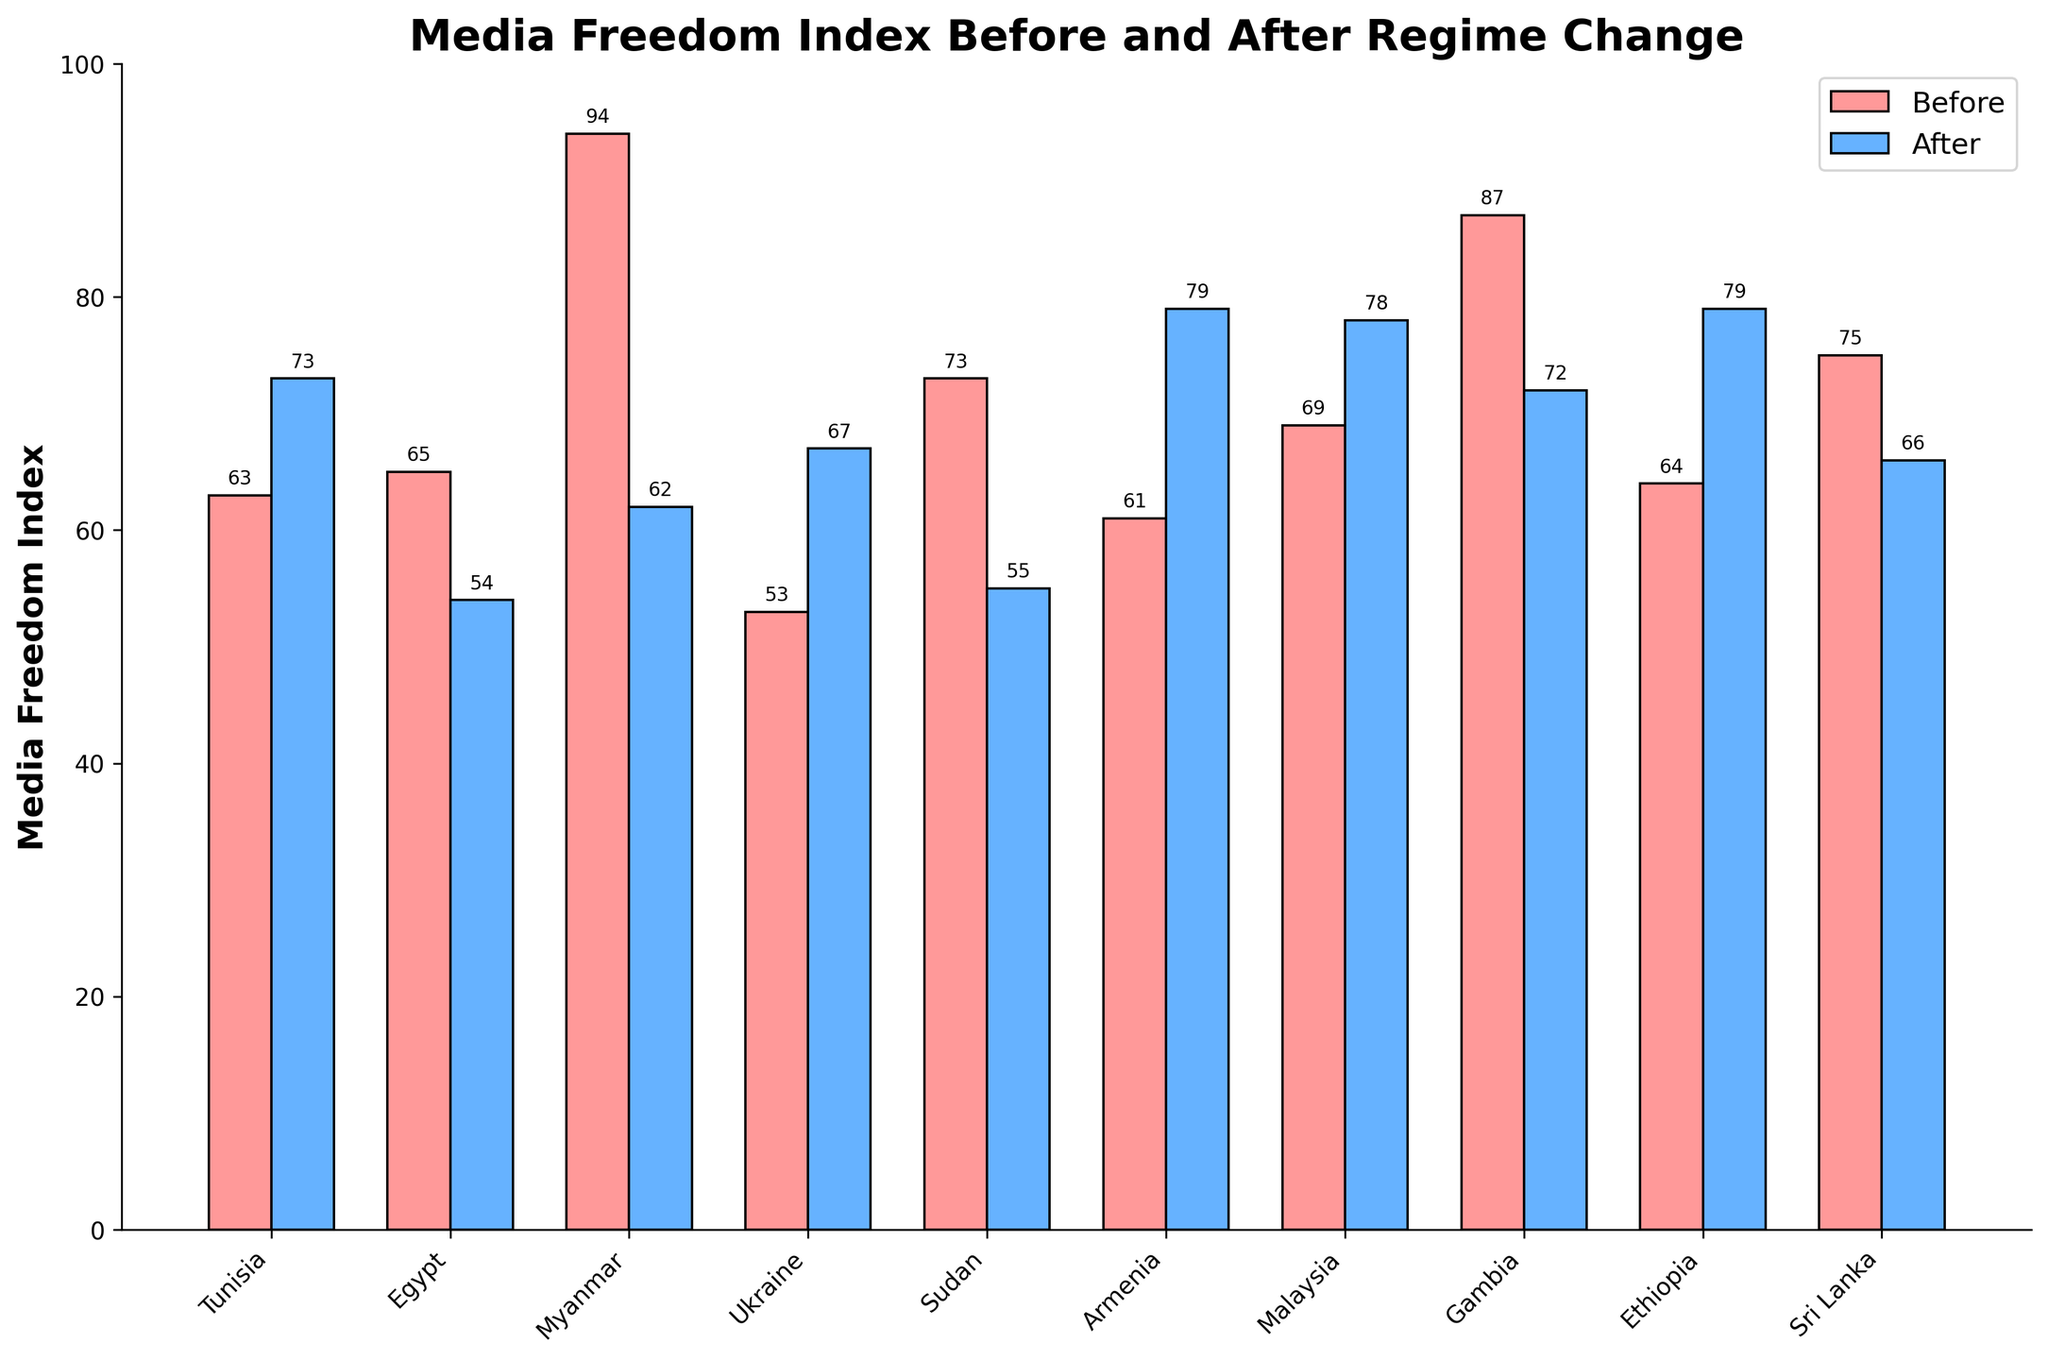Which country had the largest increase in media freedom index after regime change? Compare the "Before" and "After" values for each country and identify the one with the largest positive difference. Armenia had an increase from 61 to 79, which is 18 points, the largest increase.
Answer: Armenia Which country had a decrease in its media freedom index after regime change? Identify countries where the "After" value is less than the "Before" value. Egypt (65 to 54), Sudan (73 to 55), Sri Lanka (75 to 66), and Gambia (87 to 72) all had decreases.
Answer: Egypt, Sudan, Sri Lanka, Gambia What is the average media freedom index before regime change? Sum up all "Before" index values and divide by the number of countries: (63 + 65 + 94 + 53 + 73 + 61 + 69 + 87 + 64 + 75) / 10 = 704 / 10. The average is 70.4
Answer: 70.4 Which two countries had the smallest change in their media freedom index scores? Calculate the absolute difference between the "Before" and "After" indices for each country and identify the two smallest differences. Ukraine (-14) and Tunisia (+10). Therefore, Tunisia and Ukraine had the smallest changes.
Answer: Tunisia, Ukraine What’s the total media freedom index after regime change for all countries combined? Sum up all "After" index values: 73 + 54 + 62 + 67 + 55 + 79 + 78 + 72 + 79 + 66. Total sum is 685.
Answer: 685 Which country's media freedom index is the lowest after regime change? Compare the "After" media freedom index values and identify the smallest one. Egypt has the lowest index after regime change with 54.
Answer: Egypt By how much did Myanmar's media freedom index change after the regime change? Subtract the "After" value from the "Before" value for Myanmar. The index changed from 94 before to 62 after, so the change is 94 - 62 = 32.
Answer: 32 Which country had the highest media freedom index before regime change? Compare the "Before" values and identify the highest one. Gambia had the highest index before regime change with 87.
Answer: Gambia Which bar (before or after) is taller for Sudan, and by how much? Compare the "Before" and "After" bars for Sudan. The "Before" bar (73) is taller than the "After" bar (55). The difference is 73 - 55 = 18.
Answer: Before by 18 Among the countries with an increase in media freedom index, which one had the smallest increase? Calculate the difference between "After" and "Before" values for countries with an increase. Tunisia had the smallest increase with 10 (73 - 63).
Answer: Tunisia 